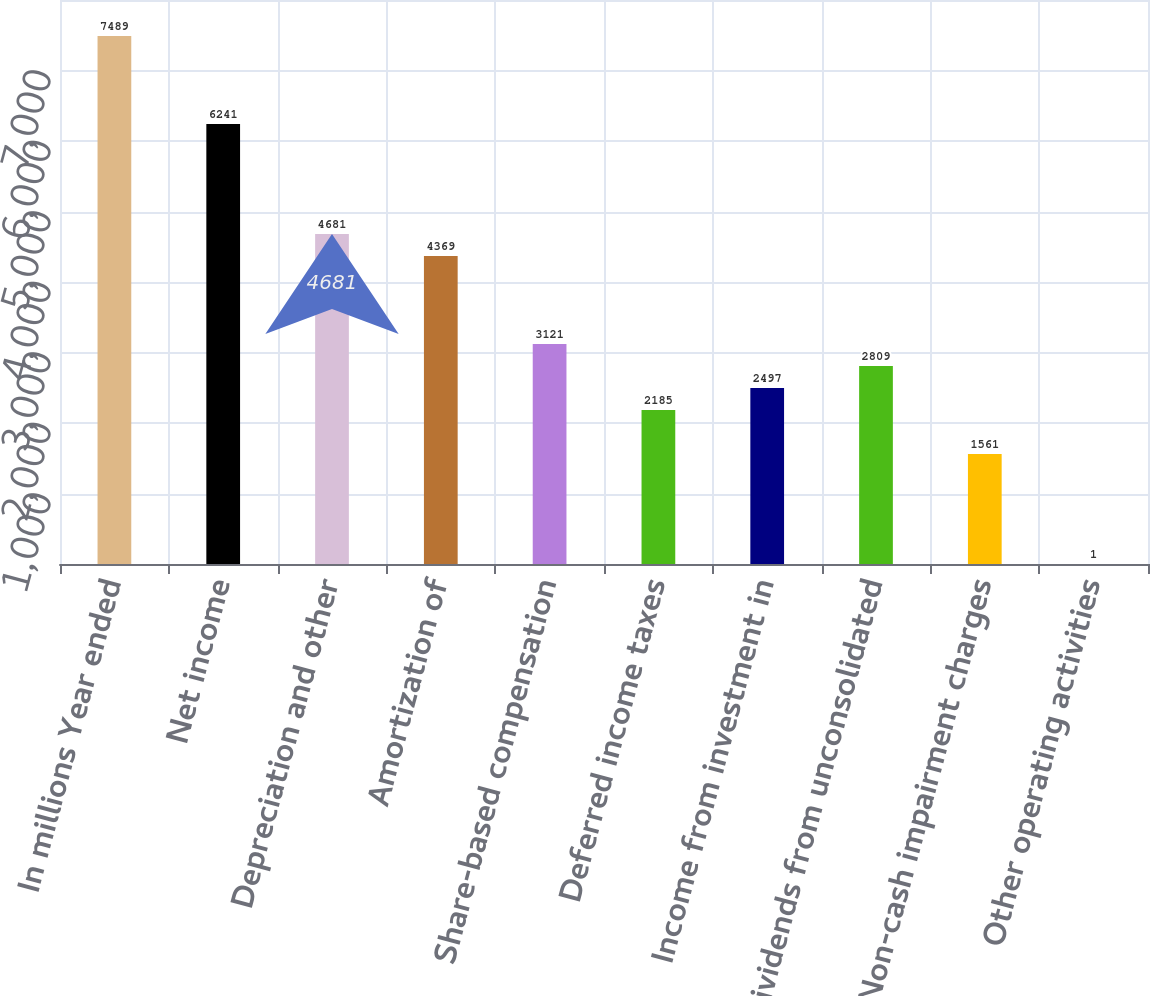Convert chart to OTSL. <chart><loc_0><loc_0><loc_500><loc_500><bar_chart><fcel>In millions Year ended<fcel>Net income<fcel>Depreciation and other<fcel>Amortization of<fcel>Share-based compensation<fcel>Deferred income taxes<fcel>Income from investment in<fcel>Dividends from unconsolidated<fcel>Non-cash impairment charges<fcel>Other operating activities<nl><fcel>7489<fcel>6241<fcel>4681<fcel>4369<fcel>3121<fcel>2185<fcel>2497<fcel>2809<fcel>1561<fcel>1<nl></chart> 